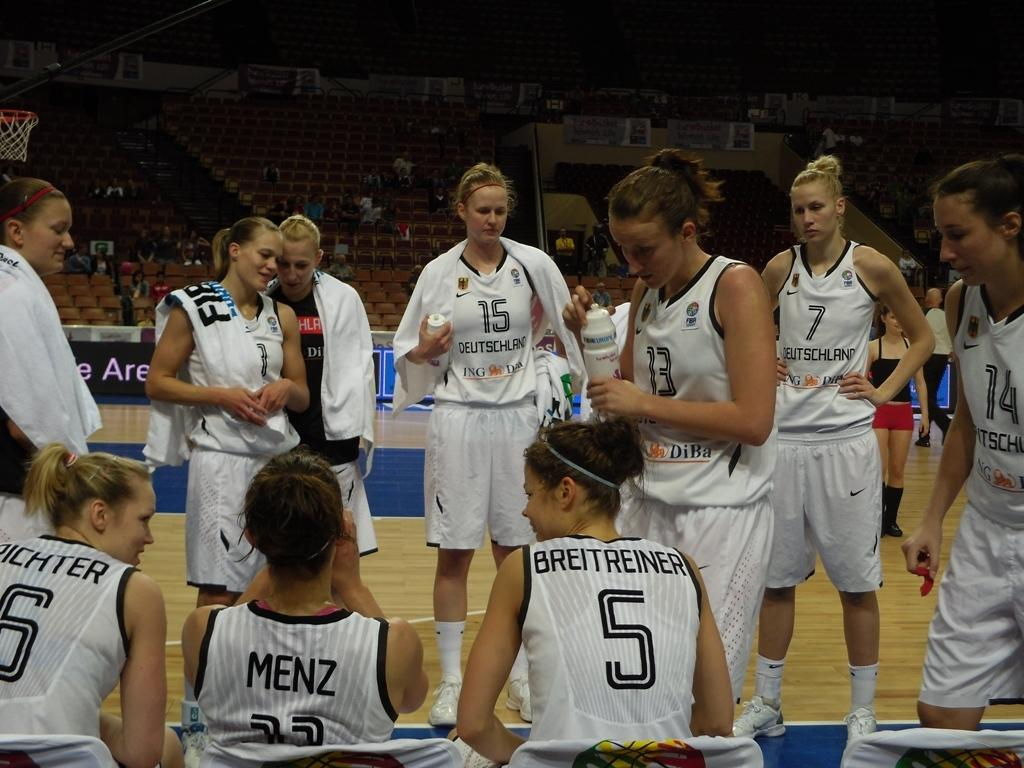<image>
Write a terse but informative summary of the picture. Menz is sitting on the sidelines with some other players. 